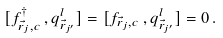Convert formula to latex. <formula><loc_0><loc_0><loc_500><loc_500>[ f _ { \vec { r } _ { j } , c } ^ { \dag } \, , q ^ { l } _ { \vec { r } _ { j ^ { \prime } } } ] = [ f _ { \vec { r } _ { j } , c } \, , q ^ { l } _ { \vec { r } _ { j ^ { \prime } } } ] = 0 \, .</formula> 